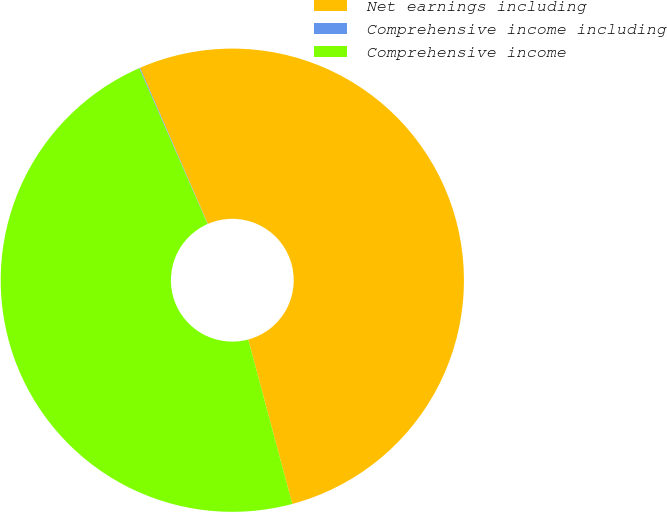<chart> <loc_0><loc_0><loc_500><loc_500><pie_chart><fcel>Net earnings including<fcel>Comprehensive income including<fcel>Comprehensive income<nl><fcel>52.36%<fcel>0.06%<fcel>47.58%<nl></chart> 